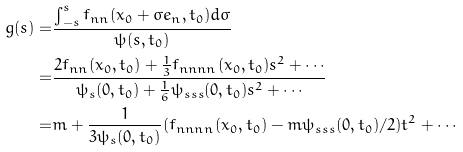Convert formula to latex. <formula><loc_0><loc_0><loc_500><loc_500>g ( s ) = & \frac { \int _ { - s } ^ { s } f _ { n n } ( x _ { 0 } + \sigma e _ { n } , t _ { 0 } ) d \sigma } { \psi ( s , t _ { 0 } ) } \\ = & \frac { 2 f _ { n n } ( x _ { 0 } , t _ { 0 } ) + \frac { 1 } { 3 } f _ { n n n n } ( x _ { 0 } , t _ { 0 } ) s ^ { 2 } + \cdots } { \psi _ { s } ( 0 , t _ { 0 } ) + \frac { 1 } { 6 } \psi _ { s s s } ( 0 , t _ { 0 } ) s ^ { 2 } + \cdots } \\ = & m + \frac { 1 } { 3 \psi _ { s } ( 0 , t _ { 0 } ) } ( f _ { n n n n } ( x _ { 0 } , t _ { 0 } ) - m \psi _ { s s s } ( 0 , t _ { 0 } ) / 2 ) t ^ { 2 } + \cdots</formula> 